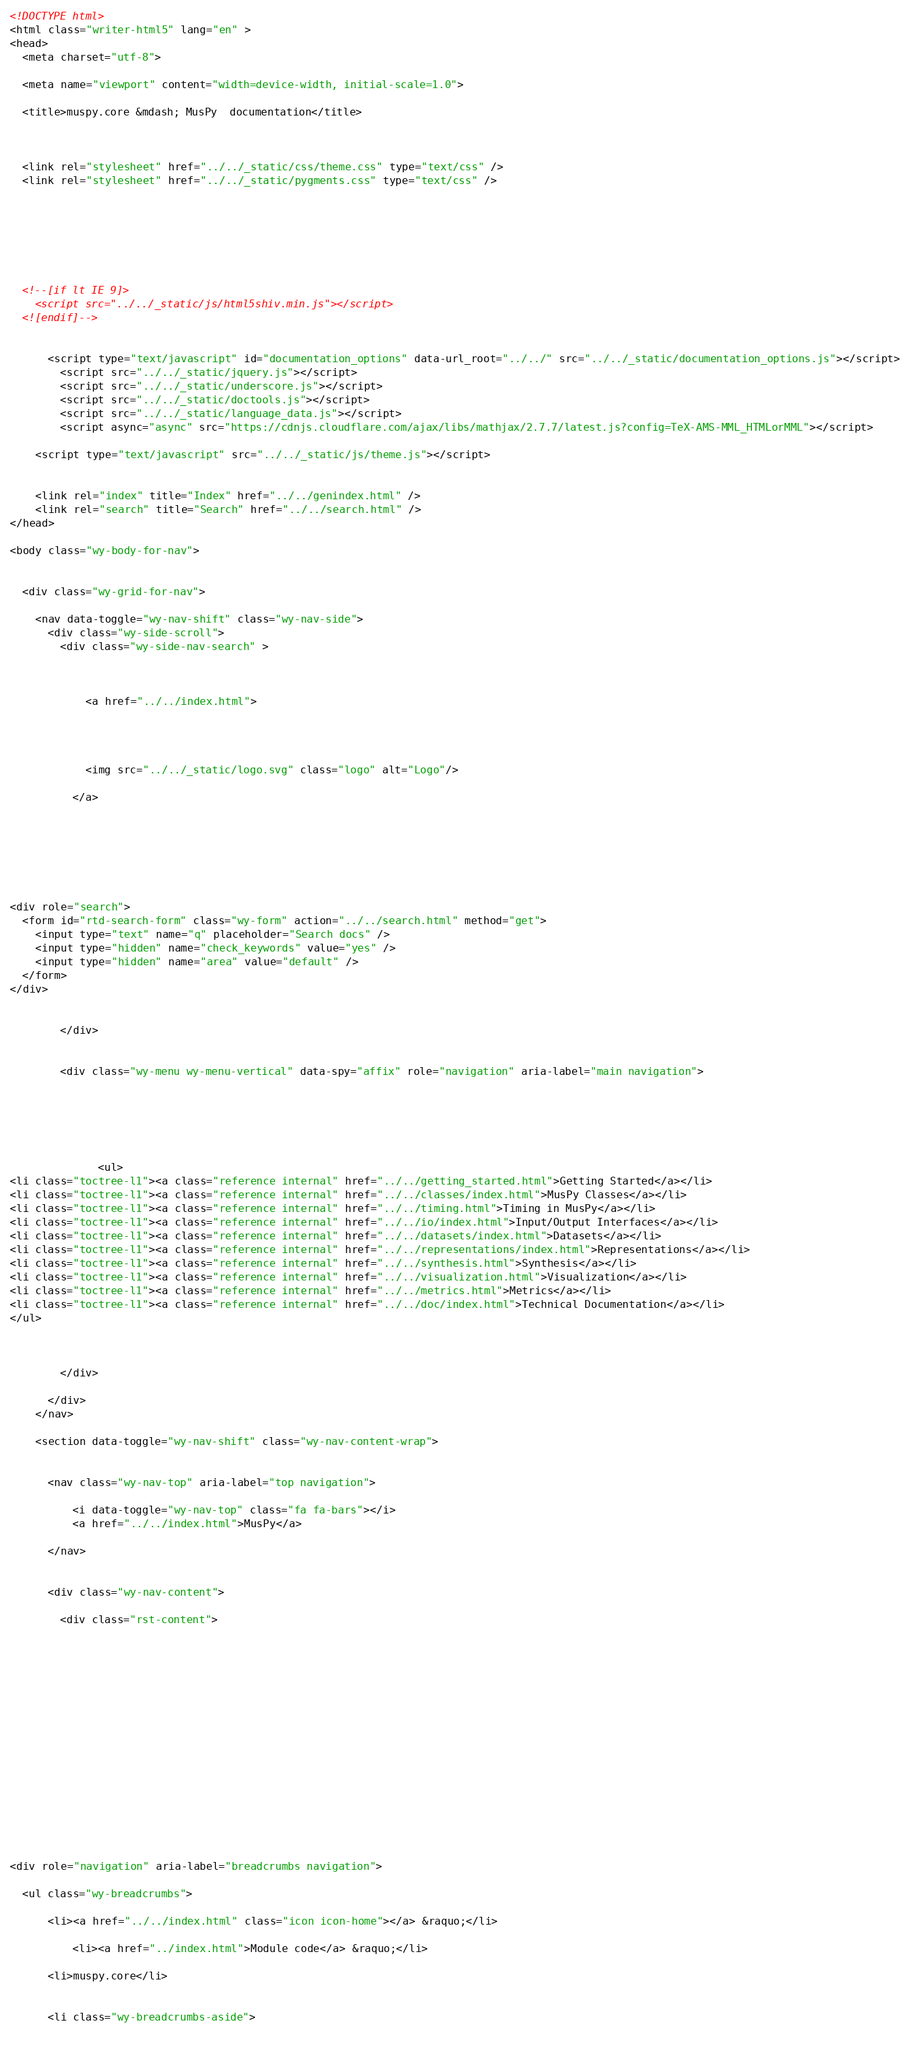Convert code to text. <code><loc_0><loc_0><loc_500><loc_500><_HTML_>

<!DOCTYPE html>
<html class="writer-html5" lang="en" >
<head>
  <meta charset="utf-8">
  
  <meta name="viewport" content="width=device-width, initial-scale=1.0">
  
  <title>muspy.core &mdash; MusPy  documentation</title>
  

  
  <link rel="stylesheet" href="../../_static/css/theme.css" type="text/css" />
  <link rel="stylesheet" href="../../_static/pygments.css" type="text/css" />

  
  
  
  

  
  <!--[if lt IE 9]>
    <script src="../../_static/js/html5shiv.min.js"></script>
  <![endif]-->
  
    
      <script type="text/javascript" id="documentation_options" data-url_root="../../" src="../../_static/documentation_options.js"></script>
        <script src="../../_static/jquery.js"></script>
        <script src="../../_static/underscore.js"></script>
        <script src="../../_static/doctools.js"></script>
        <script src="../../_static/language_data.js"></script>
        <script async="async" src="https://cdnjs.cloudflare.com/ajax/libs/mathjax/2.7.7/latest.js?config=TeX-AMS-MML_HTMLorMML"></script>
    
    <script type="text/javascript" src="../../_static/js/theme.js"></script>

    
    <link rel="index" title="Index" href="../../genindex.html" />
    <link rel="search" title="Search" href="../../search.html" /> 
</head>

<body class="wy-body-for-nav">

   
  <div class="wy-grid-for-nav">
    
    <nav data-toggle="wy-nav-shift" class="wy-nav-side">
      <div class="wy-side-scroll">
        <div class="wy-side-nav-search" >
          

          
            <a href="../../index.html">
          

          
            
            <img src="../../_static/logo.svg" class="logo" alt="Logo"/>
          
          </a>

          
            
            
          

          
<div role="search">
  <form id="rtd-search-form" class="wy-form" action="../../search.html" method="get">
    <input type="text" name="q" placeholder="Search docs" />
    <input type="hidden" name="check_keywords" value="yes" />
    <input type="hidden" name="area" value="default" />
  </form>
</div>

          
        </div>

        
        <div class="wy-menu wy-menu-vertical" data-spy="affix" role="navigation" aria-label="main navigation">
          
            
            
              
            
            
              <ul>
<li class="toctree-l1"><a class="reference internal" href="../../getting_started.html">Getting Started</a></li>
<li class="toctree-l1"><a class="reference internal" href="../../classes/index.html">MusPy Classes</a></li>
<li class="toctree-l1"><a class="reference internal" href="../../timing.html">Timing in MusPy</a></li>
<li class="toctree-l1"><a class="reference internal" href="../../io/index.html">Input/Output Interfaces</a></li>
<li class="toctree-l1"><a class="reference internal" href="../../datasets/index.html">Datasets</a></li>
<li class="toctree-l1"><a class="reference internal" href="../../representations/index.html">Representations</a></li>
<li class="toctree-l1"><a class="reference internal" href="../../synthesis.html">Synthesis</a></li>
<li class="toctree-l1"><a class="reference internal" href="../../visualization.html">Visualization</a></li>
<li class="toctree-l1"><a class="reference internal" href="../../metrics.html">Metrics</a></li>
<li class="toctree-l1"><a class="reference internal" href="../../doc/index.html">Technical Documentation</a></li>
</ul>

            
          
        </div>
        
      </div>
    </nav>

    <section data-toggle="wy-nav-shift" class="wy-nav-content-wrap">

      
      <nav class="wy-nav-top" aria-label="top navigation">
        
          <i data-toggle="wy-nav-top" class="fa fa-bars"></i>
          <a href="../../index.html">MusPy</a>
        
      </nav>


      <div class="wy-nav-content">
        
        <div class="rst-content">
        
          















<div role="navigation" aria-label="breadcrumbs navigation">

  <ul class="wy-breadcrumbs">
    
      <li><a href="../../index.html" class="icon icon-home"></a> &raquo;</li>
        
          <li><a href="../index.html">Module code</a> &raquo;</li>
        
      <li>muspy.core</li>
    
    
      <li class="wy-breadcrumbs-aside">
        </code> 